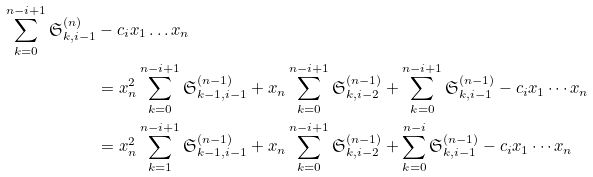Convert formula to latex. <formula><loc_0><loc_0><loc_500><loc_500>\sum _ { k = 0 } ^ { n - i + 1 } \mathfrak { S } ^ { ( n ) } _ { k , i - 1 } & - c _ { i } x _ { 1 } \dots x _ { n } \\ & = x _ { n } ^ { 2 } \sum _ { k = 0 } ^ { n - i + 1 } \mathfrak { S } ^ { ( n - 1 ) } _ { k - 1 , i - 1 } + x _ { n } \sum _ { k = 0 } ^ { n - i + 1 } \mathfrak { S } ^ { ( n - 1 ) } _ { k , i - 2 } + \sum _ { k = 0 } ^ { n - i + 1 } \mathfrak { S } ^ { ( n - 1 ) } _ { k , i - 1 } - c _ { i } x _ { 1 } \cdots x _ { n } \\ & = x _ { n } ^ { 2 } \sum _ { k = 1 } ^ { n - i + 1 } \mathfrak { S } ^ { ( n - 1 ) } _ { k - 1 , i - 1 } + x _ { n } \sum _ { k = 0 } ^ { n - i + 1 } \mathfrak { S } ^ { ( n - 1 ) } _ { k , i - 2 } + \sum _ { k = 0 } ^ { n - i } \mathfrak { S } ^ { ( n - 1 ) } _ { k , i - 1 } - c _ { i } x _ { 1 } \cdots x _ { n }</formula> 